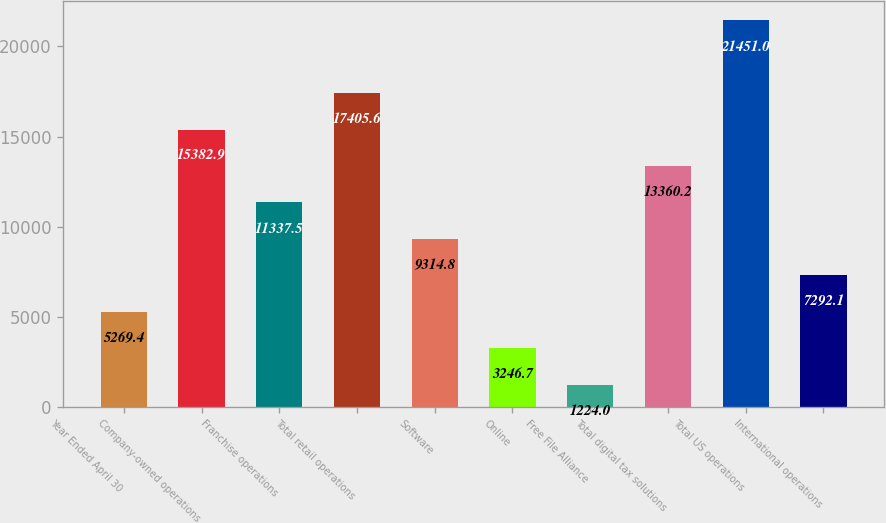Convert chart to OTSL. <chart><loc_0><loc_0><loc_500><loc_500><bar_chart><fcel>Year Ended April 30<fcel>Company-owned operations<fcel>Franchise operations<fcel>Total retail operations<fcel>Software<fcel>Online<fcel>Free File Alliance<fcel>Total digital tax solutions<fcel>Total US operations<fcel>International operations<nl><fcel>5269.4<fcel>15382.9<fcel>11337.5<fcel>17405.6<fcel>9314.8<fcel>3246.7<fcel>1224<fcel>13360.2<fcel>21451<fcel>7292.1<nl></chart> 